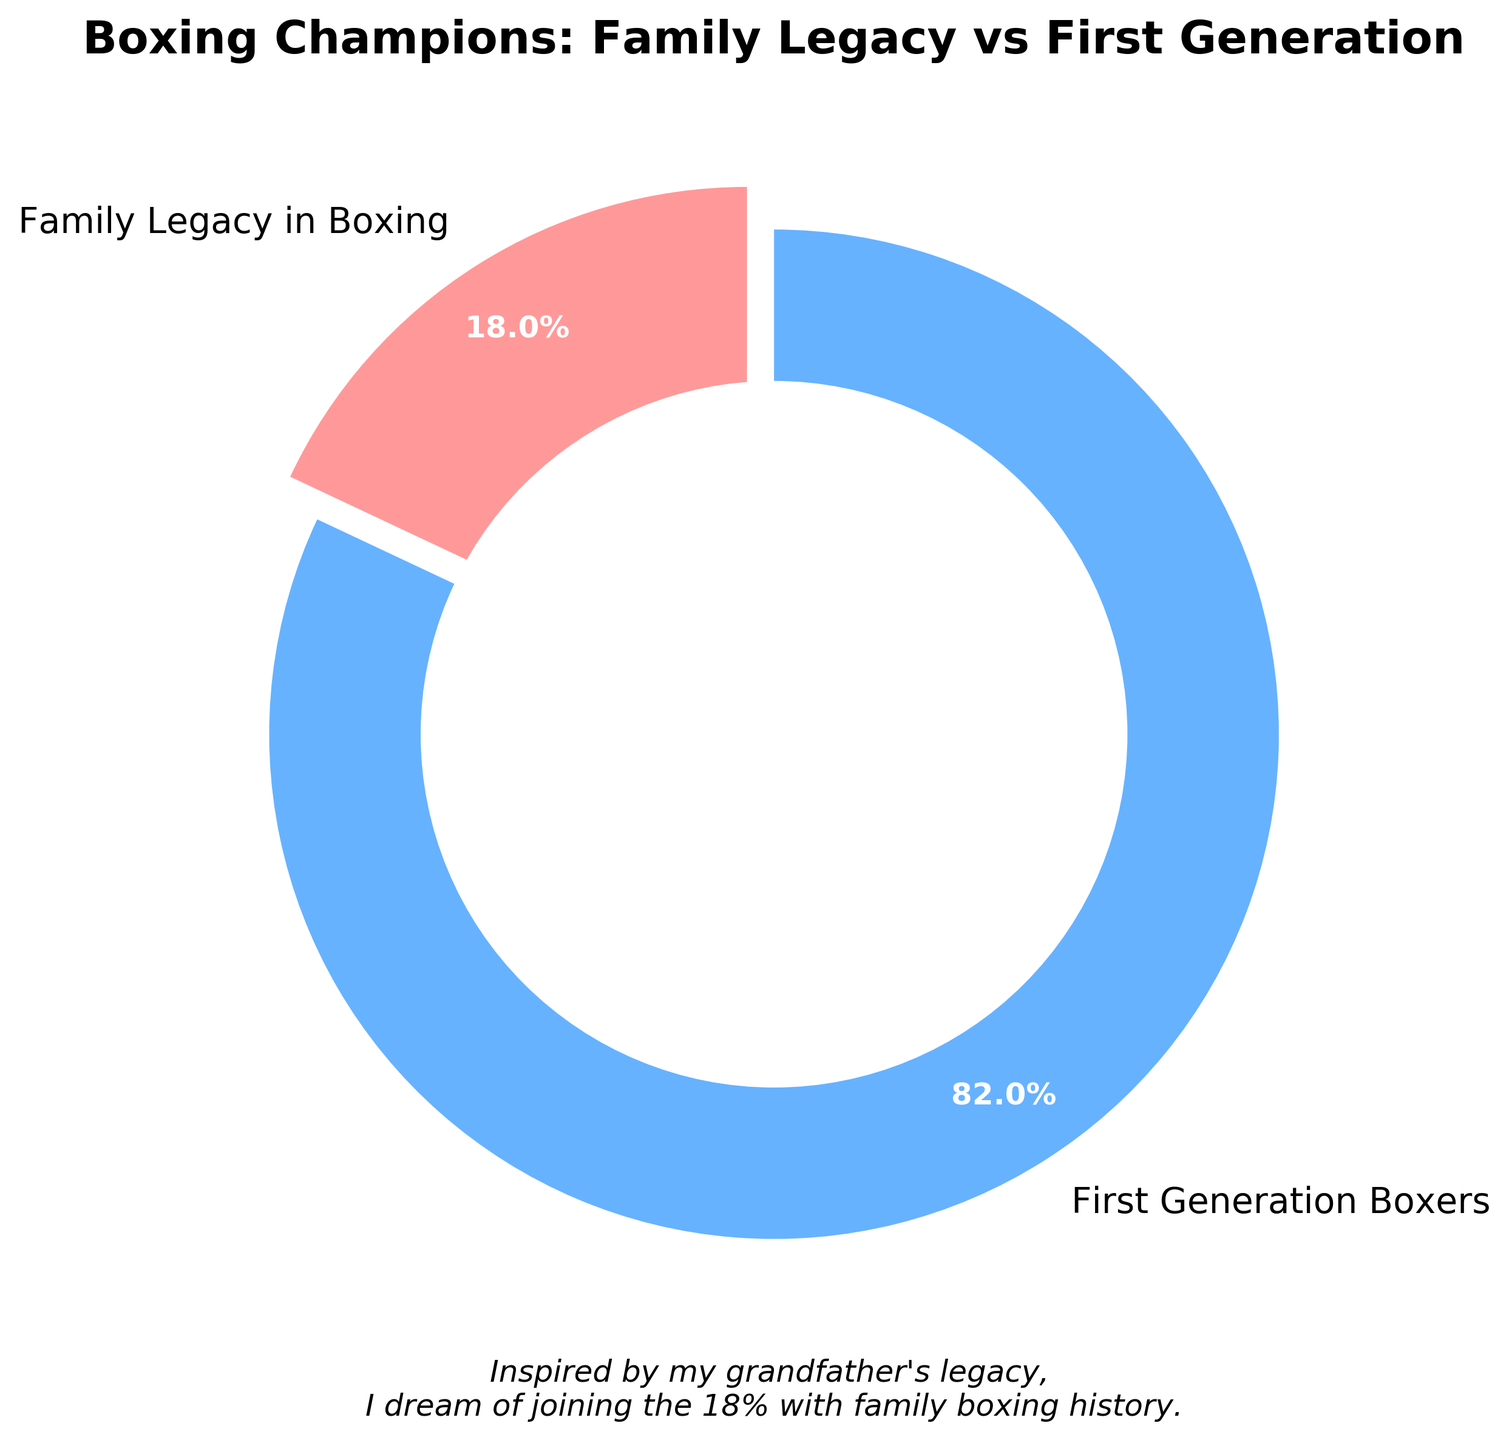Which category has the highest percentage of boxing champions? By looking at the pie chart, we observe that the "First Generation Boxers" category takes the larger portion of the pie chart. The actual percentage labeled on the chart is 82%. Thus, the highest percentage of boxing champions comes from the "First Generation Boxers."
Answer: First Generation Boxers What percentage of boxing champions come from a family legacy in the sport? The pie chart shows two categories, and we are specifically interested in "Family Legacy in Boxing." The percentage labeled on the chart for this category is 18%.
Answer: 18% What fraction of boxing champions come from a family legacy compared to the total? Convert the percentage of "Family Legacy in Boxing" champions (18%) to a fraction. Since 18% is equivalent to 18 out of 100 or 18/100, the simplest form of this fraction is 9/50.
Answer: 9/50 Is the proportion of first-generation boxers greater than those from a family legacy? By examining the pie chart, we see that the "First Generation Boxers" category is represented by a larger section of the chart (82%) compared to the "Family Legacy in Boxing" category (18%). 82% is significantly greater than 18%.
Answer: Yes How much less is the percentage of family legacy boxers compared to first-generation boxers? Subtract the percentage of "Family Legacy in Boxing" champions (18%) from the percentage of "First Generation Boxers" (82%). The difference is 82% - 18% = 64%.
Answer: 64% If there are 500 boxing champions overall, how many of them come from a family legacy? To find this, multiply the total number of boxing champions by the percentage that comes from a family legacy. That is, 500 * 18% = 500 * 0.18 = 90. So, 90 boxing champions come from a family legacy.
Answer: 90 What is the percentage gap between the two categories? The difference in percentages between "First Generation Boxers" (82%) and "Family Legacy in Boxing" (18%) is calculated as 82% - 18% = 64%. So, the gap between the two categories is 64%.
Answer: 64% Explain the significance of the text under the pie chart. The text below the pie chart states "Inspired by my grandfather's legacy, I dream of joining the 18% with family boxing history." This signifies a personal aspiration to be a part of the group of boxing champions who have a family legacy in the sport and highlights the 18% figure as being of personal importance.
Answer: Personal aspiration to join the 18% Which color represents the "First Generation Boxers" category in the pie chart? By looking at the visual attributes of the pie chart, the section representing "First Generation Boxers" is shaded in blue.
Answer: Blue What does the center circle of the chart represent? The white center circle of the chart is a design element called a "donut" chart style, which helps focus attention on the chart's central message and makes it aesthetically pleasing.
Answer: Aesthetic design choice 